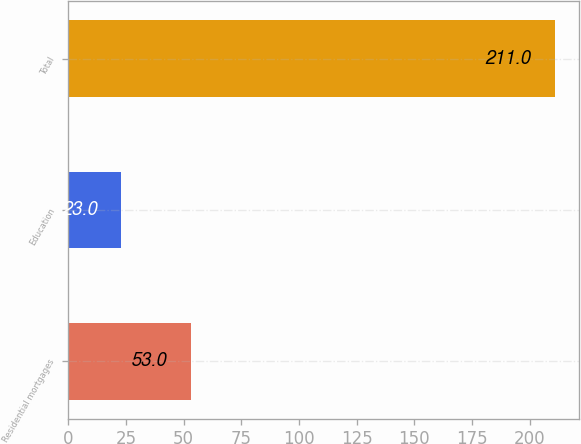Convert chart. <chart><loc_0><loc_0><loc_500><loc_500><bar_chart><fcel>Residential mortgages<fcel>Education<fcel>Total<nl><fcel>53<fcel>23<fcel>211<nl></chart> 